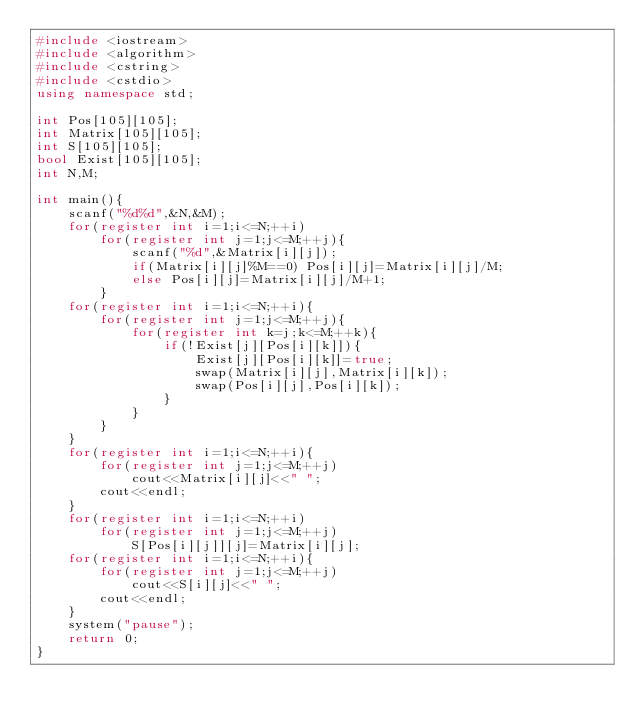Convert code to text. <code><loc_0><loc_0><loc_500><loc_500><_C++_>#include <iostream>
#include <algorithm>
#include <cstring>
#include <cstdio>
using namespace std;

int Pos[105][105];
int Matrix[105][105];
int S[105][105];
bool Exist[105][105];
int N,M;

int main(){
    scanf("%d%d",&N,&M);
    for(register int i=1;i<=N;++i)
        for(register int j=1;j<=M;++j){
            scanf("%d",&Matrix[i][j]);
            if(Matrix[i][j]%M==0) Pos[i][j]=Matrix[i][j]/M;
            else Pos[i][j]=Matrix[i][j]/M+1;
        }
    for(register int i=1;i<=N;++i){
        for(register int j=1;j<=M;++j){
            for(register int k=j;k<=M;++k){
                if(!Exist[j][Pos[i][k]]){
                    Exist[j][Pos[i][k]]=true;
                    swap(Matrix[i][j],Matrix[i][k]);
                    swap(Pos[i][j],Pos[i][k]);
                }
            }
        }
    }
    for(register int i=1;i<=N;++i){
        for(register int j=1;j<=M;++j)
            cout<<Matrix[i][j]<<" ";
        cout<<endl;
    }
    for(register int i=1;i<=N;++i)
        for(register int j=1;j<=M;++j)
            S[Pos[i][j]][j]=Matrix[i][j];
    for(register int i=1;i<=N;++i){
        for(register int j=1;j<=M;++j)
            cout<<S[i][j]<<" ";
        cout<<endl;
    }
    system("pause");
    return 0;
}</code> 